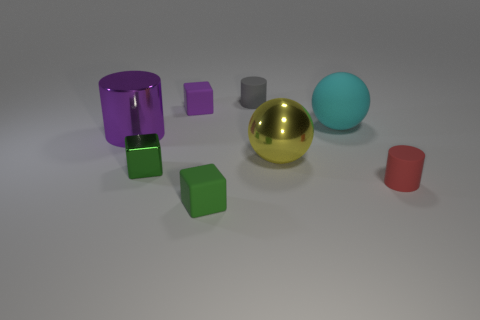Add 1 cyan balls. How many objects exist? 9 Subtract all tiny rubber cubes. How many cubes are left? 1 Subtract all cubes. How many objects are left? 5 Subtract 0 purple balls. How many objects are left? 8 Subtract all blocks. Subtract all metal cubes. How many objects are left? 4 Add 6 small gray objects. How many small gray objects are left? 7 Add 7 cubes. How many cubes exist? 10 